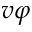<formula> <loc_0><loc_0><loc_500><loc_500>v \varphi</formula> 